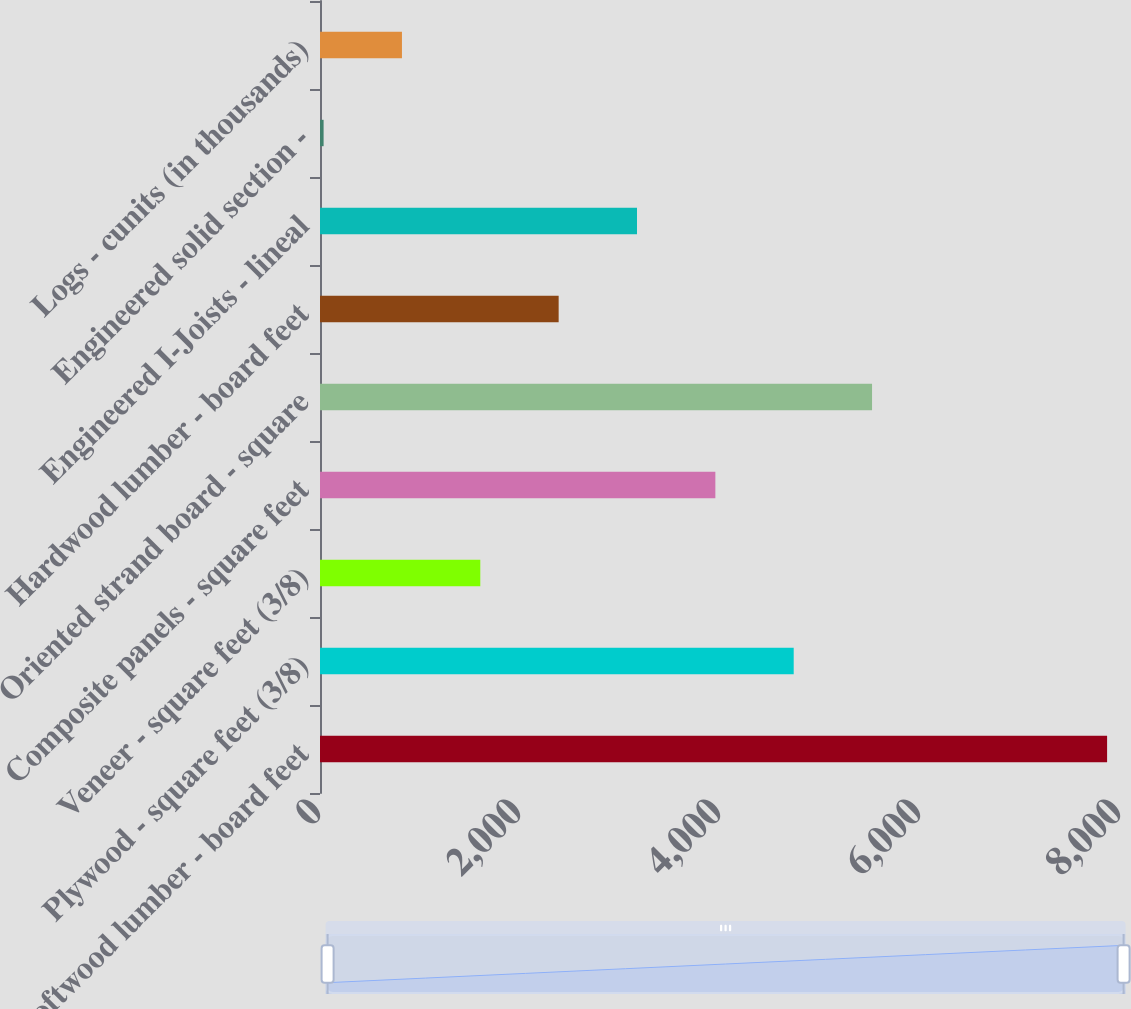Convert chart to OTSL. <chart><loc_0><loc_0><loc_500><loc_500><bar_chart><fcel>Softwood lumber - board feet<fcel>Plywood - square feet (3/8)<fcel>Veneer - square feet (3/8)<fcel>Composite panels - square feet<fcel>Oriented strand board - square<fcel>Hardwood lumber - board feet<fcel>Engineered I-Joists - lineal<fcel>Engineered solid section -<fcel>Logs - cunits (in thousands)<nl><fcel>7871<fcel>4737<fcel>1603<fcel>3953.5<fcel>5520.5<fcel>2386.5<fcel>3170<fcel>36<fcel>819.5<nl></chart> 